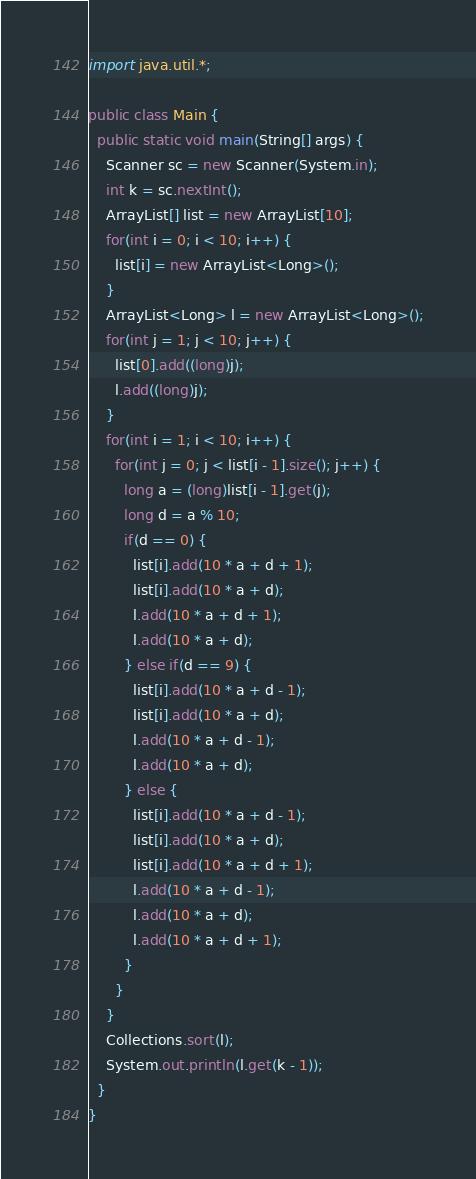<code> <loc_0><loc_0><loc_500><loc_500><_Java_>import java.util.*;

public class Main {
  public static void main(String[] args) {
    Scanner sc = new Scanner(System.in);
    int k = sc.nextInt();
    ArrayList[] list = new ArrayList[10];
    for(int i = 0; i < 10; i++) {
      list[i] = new ArrayList<Long>();
    }
    ArrayList<Long> l = new ArrayList<Long>();
    for(int j = 1; j < 10; j++) {
      list[0].add((long)j);
      l.add((long)j);
    }
    for(int i = 1; i < 10; i++) {
      for(int j = 0; j < list[i - 1].size(); j++) {
        long a = (long)list[i - 1].get(j);
        long d = a % 10;
        if(d == 0) {
          list[i].add(10 * a + d + 1);
          list[i].add(10 * a + d);
          l.add(10 * a + d + 1);
          l.add(10 * a + d);
        } else if(d == 9) {
          list[i].add(10 * a + d - 1);
          list[i].add(10 * a + d);
          l.add(10 * a + d - 1);
          l.add(10 * a + d);
        } else {
          list[i].add(10 * a + d - 1);
          list[i].add(10 * a + d);
          list[i].add(10 * a + d + 1);
          l.add(10 * a + d - 1);
          l.add(10 * a + d);
          l.add(10 * a + d + 1);
        }   
      }
    }
    Collections.sort(l);
    System.out.println(l.get(k - 1));
  }
}
</code> 